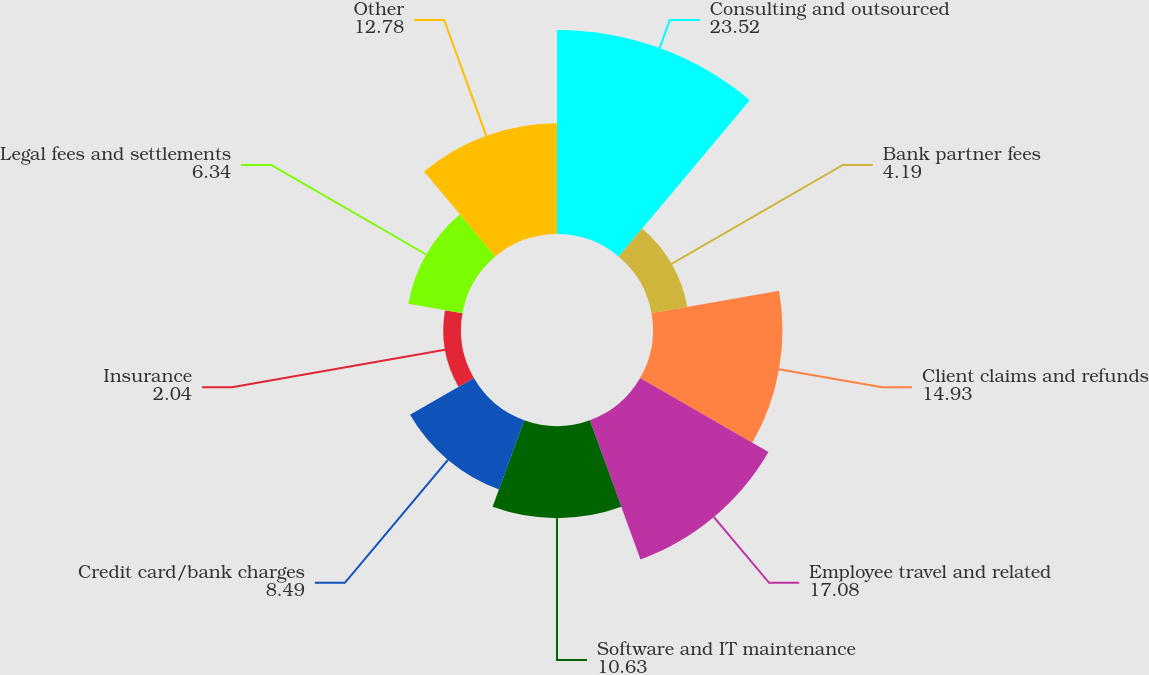<chart> <loc_0><loc_0><loc_500><loc_500><pie_chart><fcel>Consulting and outsourced<fcel>Bank partner fees<fcel>Client claims and refunds<fcel>Employee travel and related<fcel>Software and IT maintenance<fcel>Credit card/bank charges<fcel>Insurance<fcel>Legal fees and settlements<fcel>Other<nl><fcel>23.52%<fcel>4.19%<fcel>14.93%<fcel>17.08%<fcel>10.63%<fcel>8.49%<fcel>2.04%<fcel>6.34%<fcel>12.78%<nl></chart> 